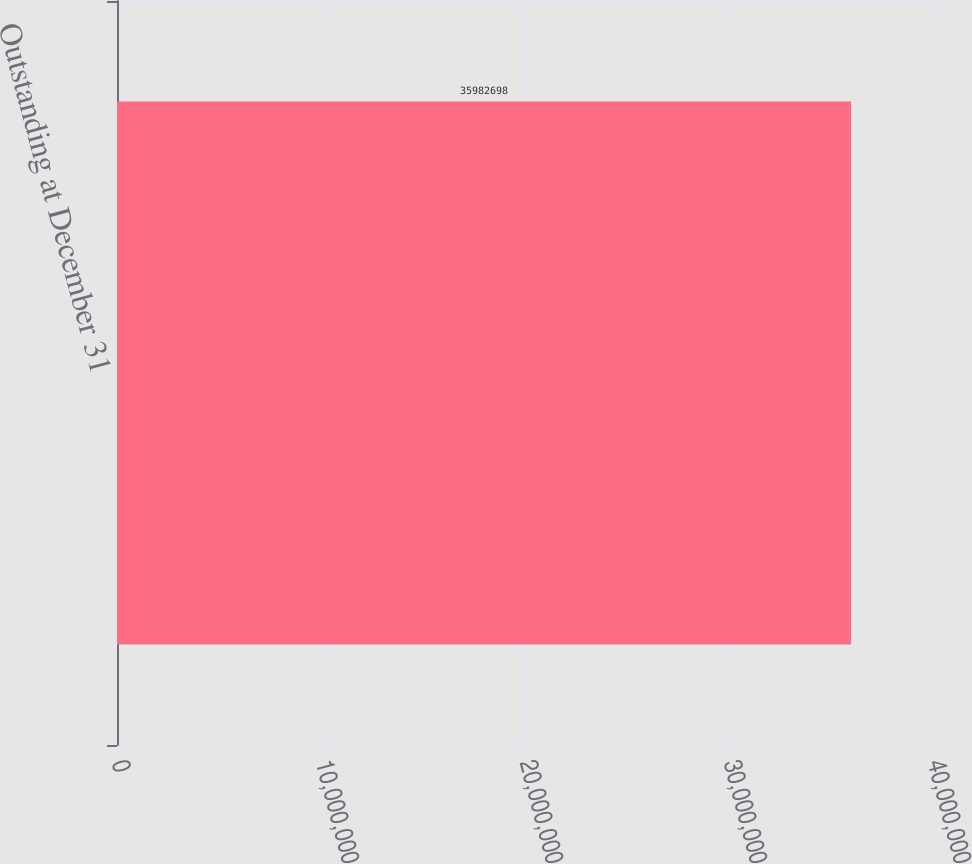Convert chart to OTSL. <chart><loc_0><loc_0><loc_500><loc_500><bar_chart><fcel>Outstanding at December 31<nl><fcel>3.59827e+07<nl></chart> 